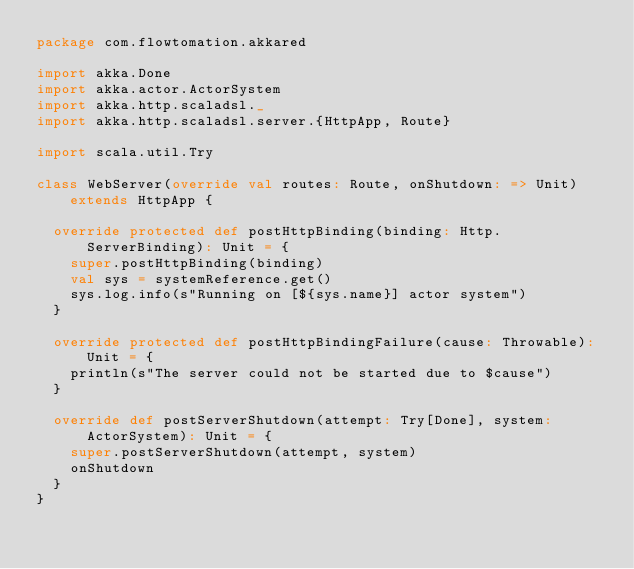Convert code to text. <code><loc_0><loc_0><loc_500><loc_500><_Scala_>package com.flowtomation.akkared

import akka.Done
import akka.actor.ActorSystem
import akka.http.scaladsl._
import akka.http.scaladsl.server.{HttpApp, Route}

import scala.util.Try

class WebServer(override val routes: Route, onShutdown: => Unit) extends HttpApp {

  override protected def postHttpBinding(binding: Http.ServerBinding): Unit = {
    super.postHttpBinding(binding)
    val sys = systemReference.get()
    sys.log.info(s"Running on [${sys.name}] actor system")
  }

  override protected def postHttpBindingFailure(cause: Throwable): Unit = {
    println(s"The server could not be started due to $cause")
  }

  override def postServerShutdown(attempt: Try[Done], system: ActorSystem): Unit = {
    super.postServerShutdown(attempt, system)
    onShutdown
  }
}
</code> 